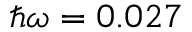Convert formula to latex. <formula><loc_0><loc_0><loc_500><loc_500>{ } \omega = 0 . 0 2 7</formula> 